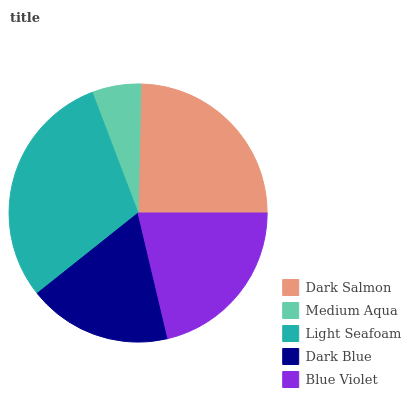Is Medium Aqua the minimum?
Answer yes or no. Yes. Is Light Seafoam the maximum?
Answer yes or no. Yes. Is Light Seafoam the minimum?
Answer yes or no. No. Is Medium Aqua the maximum?
Answer yes or no. No. Is Light Seafoam greater than Medium Aqua?
Answer yes or no. Yes. Is Medium Aqua less than Light Seafoam?
Answer yes or no. Yes. Is Medium Aqua greater than Light Seafoam?
Answer yes or no. No. Is Light Seafoam less than Medium Aqua?
Answer yes or no. No. Is Blue Violet the high median?
Answer yes or no. Yes. Is Blue Violet the low median?
Answer yes or no. Yes. Is Dark Salmon the high median?
Answer yes or no. No. Is Dark Salmon the low median?
Answer yes or no. No. 